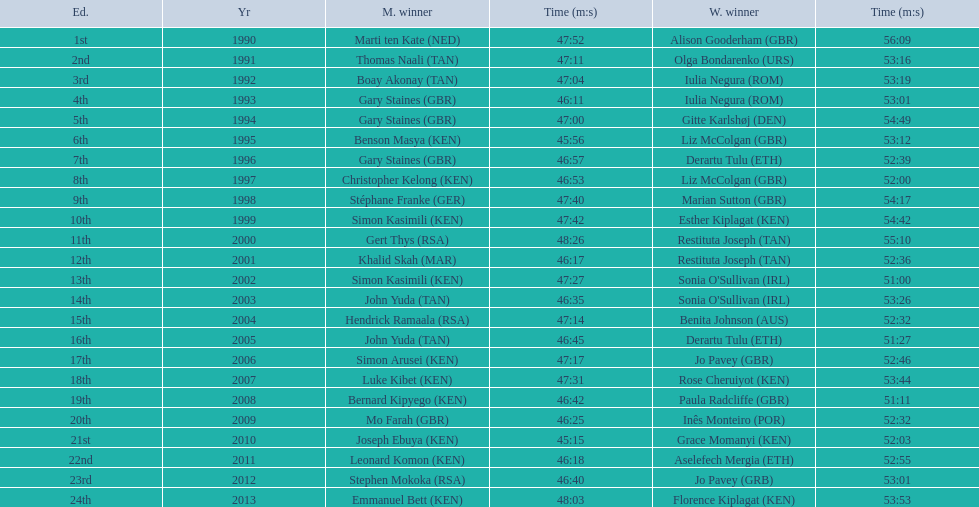Who were all the runners' times between 1990 and 2013? 47:52, 56:09, 47:11, 53:16, 47:04, 53:19, 46:11, 53:01, 47:00, 54:49, 45:56, 53:12, 46:57, 52:39, 46:53, 52:00, 47:40, 54:17, 47:42, 54:42, 48:26, 55:10, 46:17, 52:36, 47:27, 51:00, 46:35, 53:26, 47:14, 52:32, 46:45, 51:27, 47:17, 52:46, 47:31, 53:44, 46:42, 51:11, 46:25, 52:32, 45:15, 52:03, 46:18, 52:55, 46:40, 53:01, 48:03, 53:53. Which was the fastest time? 45:15. Who ran that time? Joseph Ebuya (KEN). Can you give me this table as a dict? {'header': ['Ed.', 'Yr', 'M. winner', 'Time (m:s)', 'W. winner', 'Time (m:s)'], 'rows': [['1st', '1990', 'Marti ten Kate\xa0(NED)', '47:52', 'Alison Gooderham\xa0(GBR)', '56:09'], ['2nd', '1991', 'Thomas Naali\xa0(TAN)', '47:11', 'Olga Bondarenko\xa0(URS)', '53:16'], ['3rd', '1992', 'Boay Akonay\xa0(TAN)', '47:04', 'Iulia Negura\xa0(ROM)', '53:19'], ['4th', '1993', 'Gary Staines\xa0(GBR)', '46:11', 'Iulia Negura\xa0(ROM)', '53:01'], ['5th', '1994', 'Gary Staines\xa0(GBR)', '47:00', 'Gitte Karlshøj\xa0(DEN)', '54:49'], ['6th', '1995', 'Benson Masya\xa0(KEN)', '45:56', 'Liz McColgan\xa0(GBR)', '53:12'], ['7th', '1996', 'Gary Staines\xa0(GBR)', '46:57', 'Derartu Tulu\xa0(ETH)', '52:39'], ['8th', '1997', 'Christopher Kelong\xa0(KEN)', '46:53', 'Liz McColgan\xa0(GBR)', '52:00'], ['9th', '1998', 'Stéphane Franke\xa0(GER)', '47:40', 'Marian Sutton\xa0(GBR)', '54:17'], ['10th', '1999', 'Simon Kasimili\xa0(KEN)', '47:42', 'Esther Kiplagat\xa0(KEN)', '54:42'], ['11th', '2000', 'Gert Thys\xa0(RSA)', '48:26', 'Restituta Joseph\xa0(TAN)', '55:10'], ['12th', '2001', 'Khalid Skah\xa0(MAR)', '46:17', 'Restituta Joseph\xa0(TAN)', '52:36'], ['13th', '2002', 'Simon Kasimili\xa0(KEN)', '47:27', "Sonia O'Sullivan\xa0(IRL)", '51:00'], ['14th', '2003', 'John Yuda\xa0(TAN)', '46:35', "Sonia O'Sullivan\xa0(IRL)", '53:26'], ['15th', '2004', 'Hendrick Ramaala\xa0(RSA)', '47:14', 'Benita Johnson\xa0(AUS)', '52:32'], ['16th', '2005', 'John Yuda\xa0(TAN)', '46:45', 'Derartu Tulu\xa0(ETH)', '51:27'], ['17th', '2006', 'Simon Arusei\xa0(KEN)', '47:17', 'Jo Pavey\xa0(GBR)', '52:46'], ['18th', '2007', 'Luke Kibet\xa0(KEN)', '47:31', 'Rose Cheruiyot\xa0(KEN)', '53:44'], ['19th', '2008', 'Bernard Kipyego\xa0(KEN)', '46:42', 'Paula Radcliffe\xa0(GBR)', '51:11'], ['20th', '2009', 'Mo Farah\xa0(GBR)', '46:25', 'Inês Monteiro\xa0(POR)', '52:32'], ['21st', '2010', 'Joseph Ebuya\xa0(KEN)', '45:15', 'Grace Momanyi\xa0(KEN)', '52:03'], ['22nd', '2011', 'Leonard Komon\xa0(KEN)', '46:18', 'Aselefech Mergia\xa0(ETH)', '52:55'], ['23rd', '2012', 'Stephen Mokoka\xa0(RSA)', '46:40', 'Jo Pavey\xa0(GRB)', '53:01'], ['24th', '2013', 'Emmanuel Bett\xa0(KEN)', '48:03', 'Florence Kiplagat\xa0(KEN)', '53:53']]} 